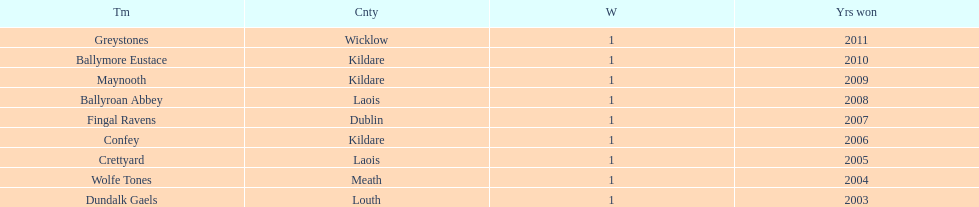What team comes before confey Fingal Ravens. 